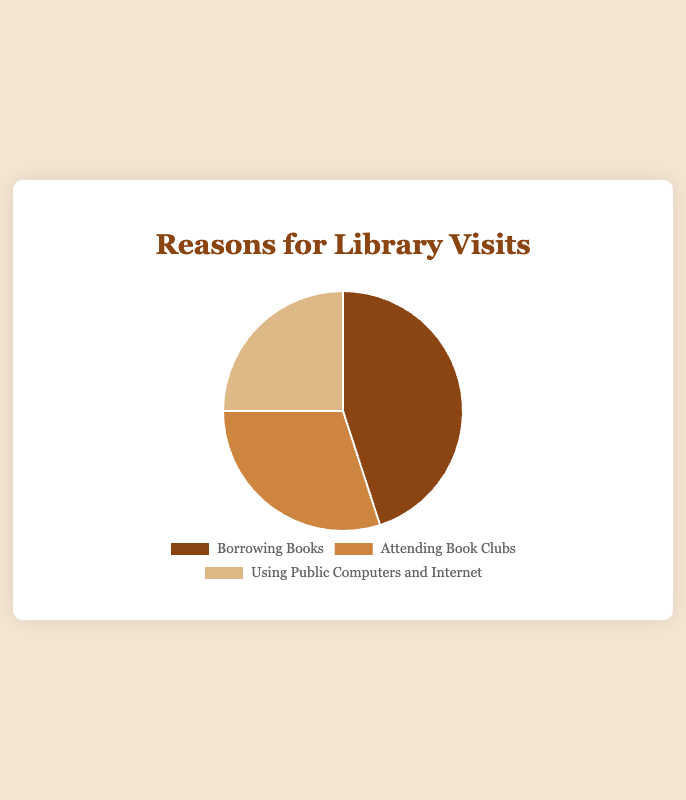what are the three reasons for library visits shown in the pie chart? The pie chart displays three main reasons for library visits: Borrowing Books, Attending Book Clubs, and Using Public Computers and Internet. These categories are illustrated with different sections on the pie chart.
Answer: Borrowing Books, Attending Book Clubs, Using Public Computers and Internet which reason has the highest percentage of library visits? Among the three reasons shown in the pie chart, Borrowing Books occupies the largest section, indicating it has the highest percentage. The label shows 45% for Borrowing Books.
Answer: Borrowing Books how much more percentage does borrowing books have compared to attending book clubs? Borrowing Books has 45% and Attending Book Clubs has 30%. To find the difference, subtract 30 from 45.
Answer: 15% what is the total percentage of people visiting the library for borrowing books and using public computers and internet combined? The pie chart shows Borrowing Books at 45% and Using Public Computers and Internet at 25%. Adding these together: 45 + 25 = 70.
Answer: 70% which reason is indicated with a darker color on the pie chart? In the visual presentation, Borrowing Books is represented with the darkest color among the three sections, likely corresponding to a brown shade. Confirm this by noticing that darker colors usually occupy larger or more significant sections in pie charts.
Answer: Borrowing Books is the percentage of people using public computers and internet higher or lower than those attending book clubs? According to the pie chart, Using Public Computers and Internet has 25%, whereas Attending Book Clubs has 30%. Since 25 is less than 30, the percentage for Using Public Computers and Internet is lower.
Answer: Lower what is the average percentage of all the reasons combined? To find the average, add up all the percentages and divide by the number of reasons. (45 + 30 + 25) / 3 = 100 / 3 ≈ 33.33.
Answer: 33.33% which two reasons together make up more than half of the total library visits? Borrowing Books has 45% and Attending Book Clubs has 30%. Adding these together: 45 + 30 = 75. This is more than half (50%) of the total.
Answer: Borrowing Books and Attending Book Clubs 